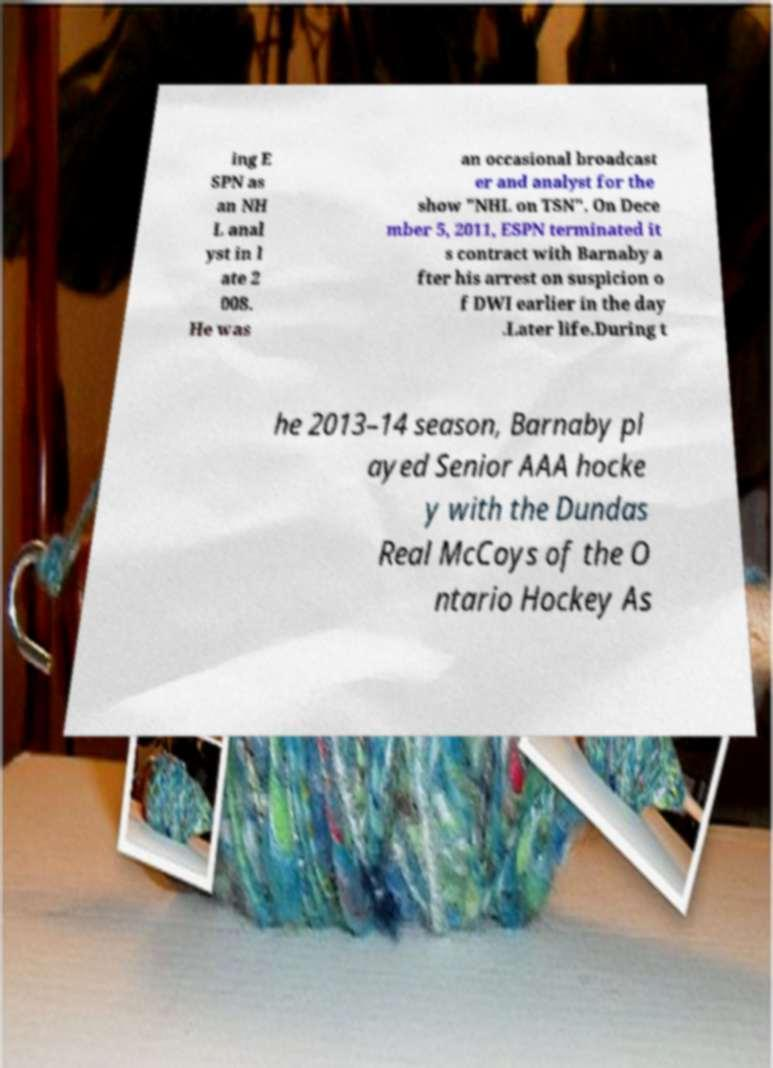I need the written content from this picture converted into text. Can you do that? ing E SPN as an NH L anal yst in l ate 2 008. He was an occasional broadcast er and analyst for the show "NHL on TSN". On Dece mber 5, 2011, ESPN terminated it s contract with Barnaby a fter his arrest on suspicion o f DWI earlier in the day .Later life.During t he 2013–14 season, Barnaby pl ayed Senior AAA hocke y with the Dundas Real McCoys of the O ntario Hockey As 